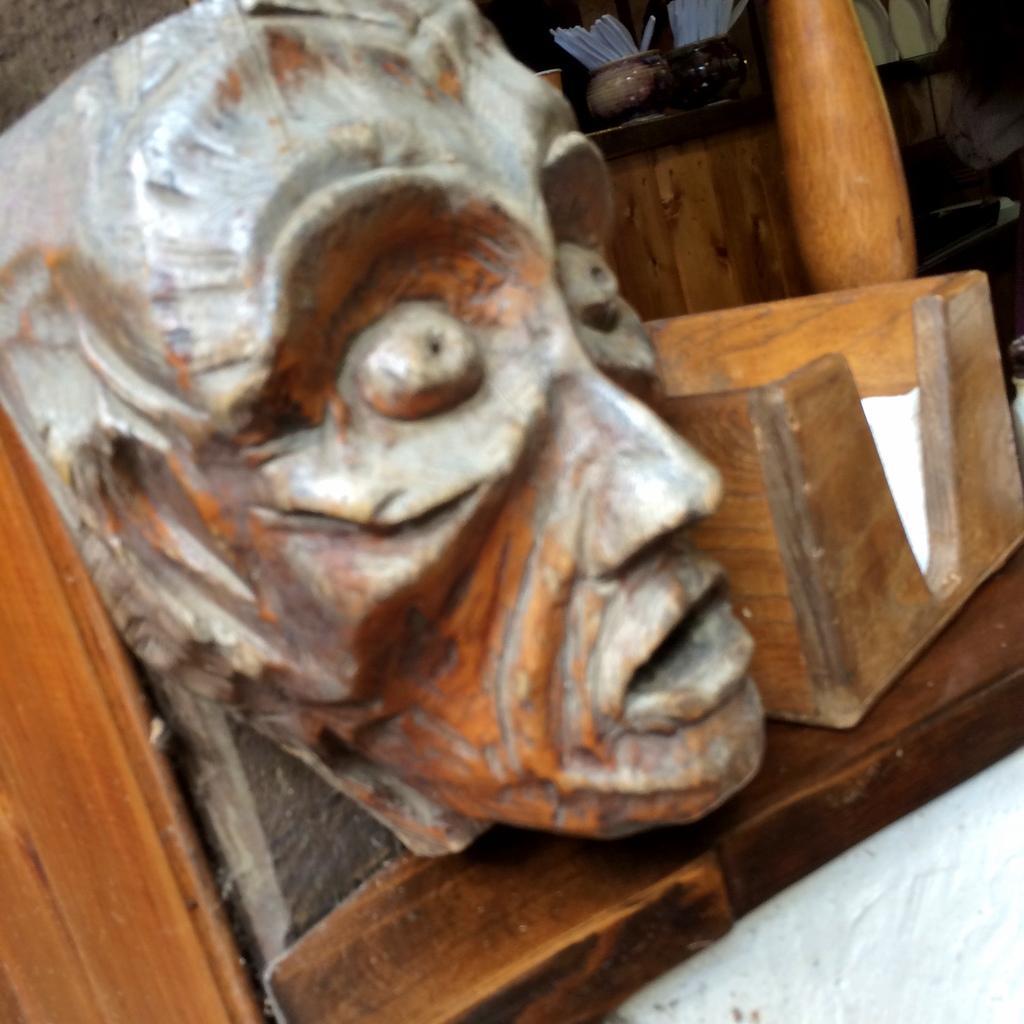In one or two sentences, can you explain what this image depicts? Here in this picture we can see a carved stone made in to a face present over a place and beside it we can see a wooden box present over there and in the far we can see a bowl with somethings present on the table over there. 